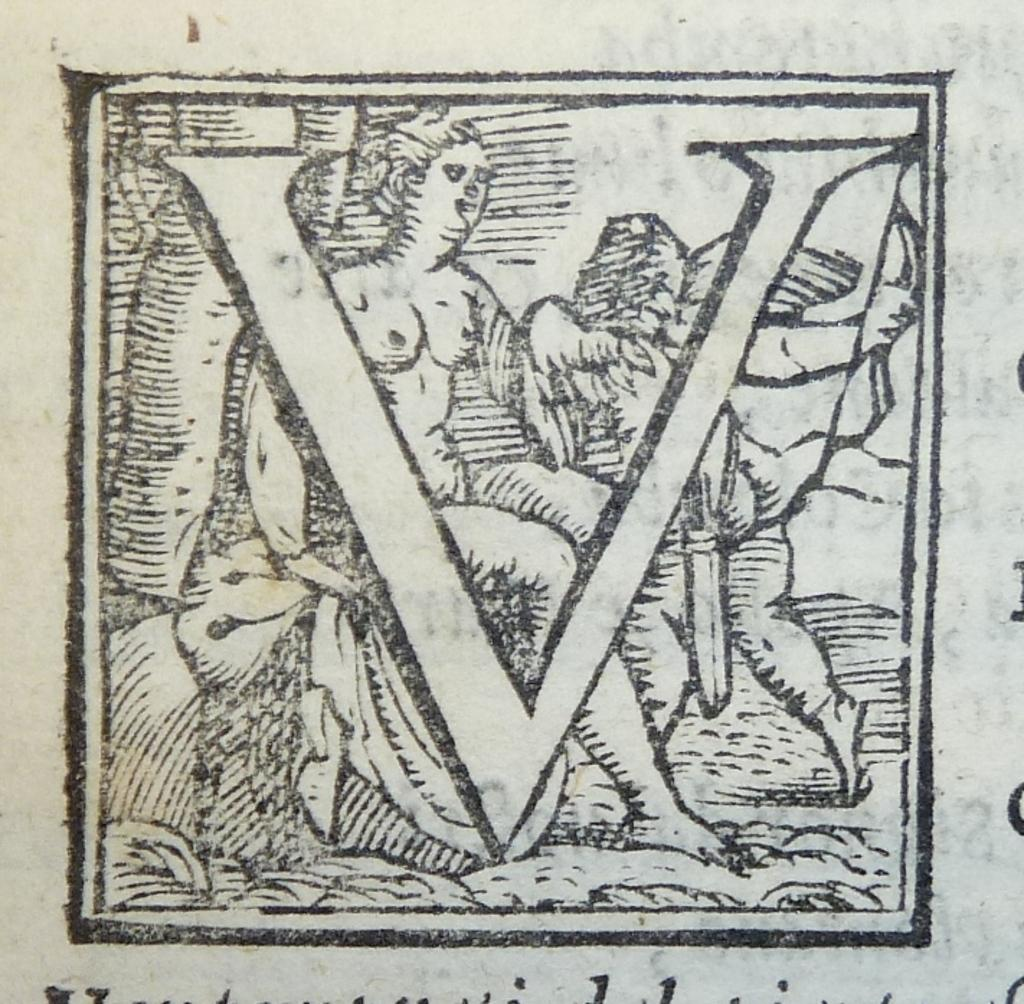What is the main subject of the image? The main subject of the image is a sketch of a person. What else is present in the image besides the sketch? There is an alphabet and text at the bottom of the image. Can you tell me where the map is located in the image? There is no map present in the image; it contains a sketch of a person, an alphabet, and text at the bottom. 